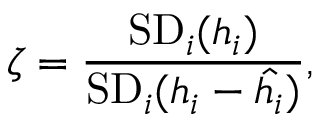Convert formula to latex. <formula><loc_0><loc_0><loc_500><loc_500>\zeta = \frac { S D _ { i } ( h _ { i } ) } { S D _ { i } ( h _ { i } - \hat { h _ { i } } ) } ,</formula> 